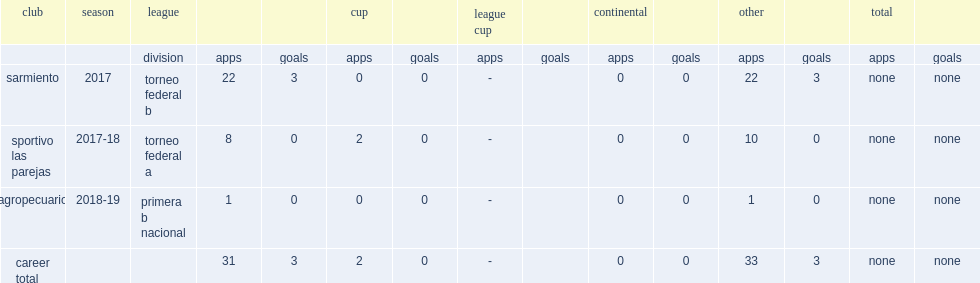How many goals did seimandi score for sarmiento in 2017? 3.0. 